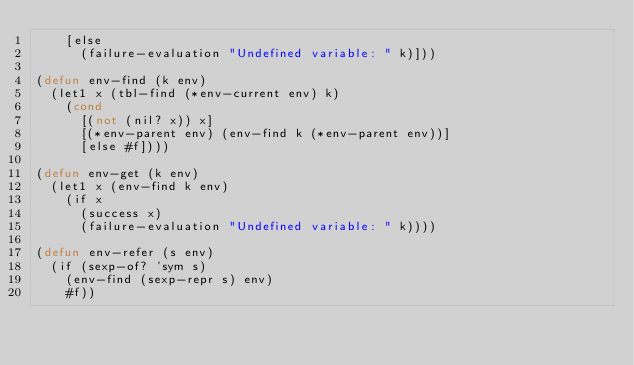Convert code to text. <code><loc_0><loc_0><loc_500><loc_500><_Lisp_>    [else
      (failure-evaluation "Undefined variable: " k)]))

(defun env-find (k env)
  (let1 x (tbl-find (*env-current env) k)
    (cond
      [(not (nil? x)) x]
      [(*env-parent env) (env-find k (*env-parent env))]
      [else #f])))

(defun env-get (k env)
  (let1 x (env-find k env)
    (if x
      (success x)
      (failure-evaluation "Undefined variable: " k))))

(defun env-refer (s env)
  (if (sexp-of? 'sym s)
    (env-find (sexp-repr s) env)
    #f))
</code> 